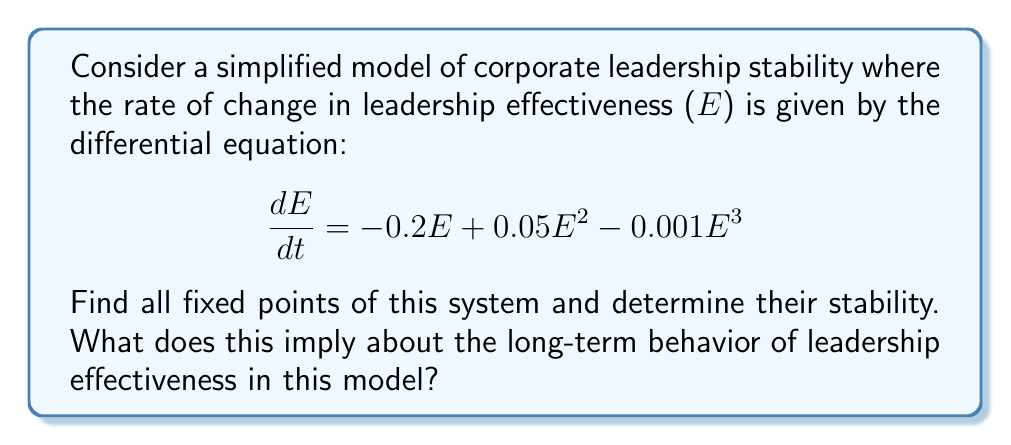Show me your answer to this math problem. 1) To find the fixed points, we set $\frac{dE}{dt} = 0$:

   $$-0.2E + 0.05E^2 - 0.001E^3 = 0$$

2) Factor out E:

   $$E(-0.2 + 0.05E - 0.001E^2) = 0$$

3) Solve the equation:
   - E = 0 is one solution
   - For the quadratic part: $-0.2 + 0.05E - 0.001E^2 = 0$
   - Using the quadratic formula, we get E ≈ 4.95 and E ≈ 45.05

4) Therefore, the fixed points are E = 0, E ≈ 4.95, and E ≈ 45.05

5) To determine stability, we evaluate $\frac{d}{dE}(\frac{dE}{dt})$ at each fixed point:

   $$\frac{d}{dE}(\frac{dE}{dt}) = -0.2 + 0.1E - 0.003E^2$$

6) Evaluate at each fixed point:
   - At E = 0: $-0.2 < 0$ (stable)
   - At E ≈ 4.95: $-0.2 + 0.495 - 0.074 ≈ 0.221 > 0$ (unstable)
   - At E ≈ 45.05: $-0.2 + 4.505 - 6.083 ≈ -1.778 < 0$ (stable)

7) Interpretation: The system has two stable fixed points (0 and 45.05) and one unstable fixed point (4.95). This implies that in the long term, leadership effectiveness will tend towards either complete ineffectiveness (0) or high effectiveness (45.05), depending on the initial conditions. The middle point (4.95) represents a threshold that separates these two outcomes.
Answer: Two stable fixed points (0 and 45.05) and one unstable fixed point (4.95), indicating bistable long-term behavior in leadership effectiveness. 